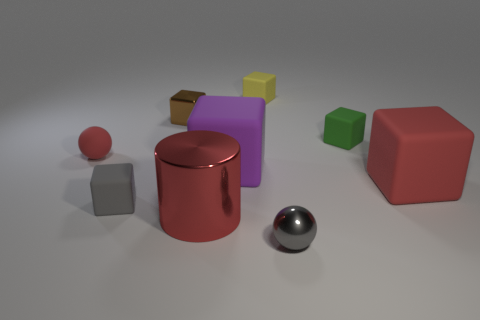How big is the red rubber cube?
Offer a terse response. Large. What is the size of the gray object that is the same shape as the tiny red rubber thing?
Your response must be concise. Small. What number of metallic things are in front of the red sphere?
Your answer should be very brief. 2. What is the color of the big rubber cube left of the ball that is to the right of the gray matte object?
Make the answer very short. Purple. Is there anything else that has the same shape as the small yellow thing?
Your response must be concise. Yes. Is the number of metallic things that are behind the cylinder the same as the number of small brown things that are in front of the green matte block?
Provide a short and direct response. No. How many balls are either green metal objects or yellow rubber things?
Make the answer very short. 0. What number of other things are made of the same material as the brown cube?
Provide a short and direct response. 2. There is a red rubber thing that is to the left of the brown thing; what shape is it?
Provide a succinct answer. Sphere. What is the tiny sphere that is left of the tiny shiny thing that is behind the tiny gray matte block made of?
Provide a succinct answer. Rubber. 